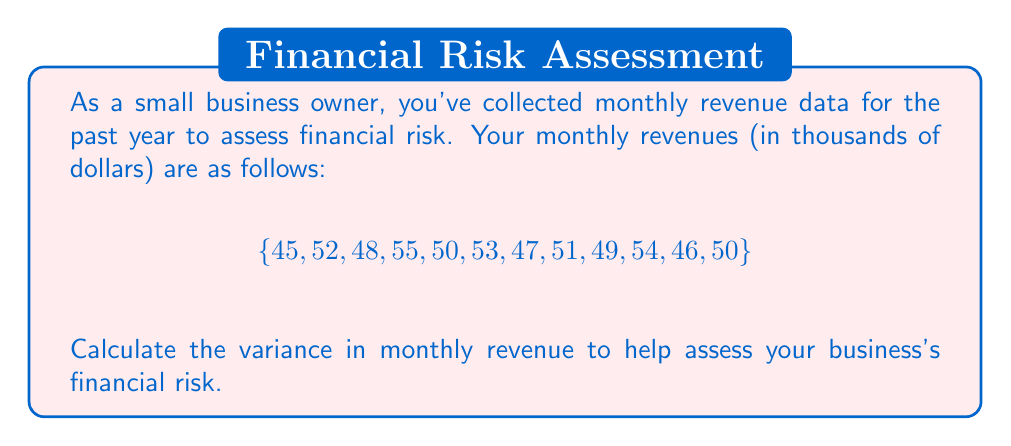Show me your answer to this math problem. To calculate the variance, we'll follow these steps:

1. Calculate the mean (average) revenue:
   $$\mu = \frac{\sum_{i=1}^{n} x_i}{n} = \frac{45 + 52 + 48 + 55 + 50 + 53 + 47 + 51 + 49 + 54 + 46 + 50}{12} = 50$$

2. Calculate the squared differences from the mean:
   $$(45-50)^2 = 25, (52-50)^2 = 4, (48-50)^2 = 4, (55-50)^2 = 25, (50-50)^2 = 0,$$
   $$(53-50)^2 = 9, (47-50)^2 = 9, (51-50)^2 = 1, (49-50)^2 = 1, (54-50)^2 = 16,$$
   $$(46-50)^2 = 16, (50-50)^2 = 0$$

3. Sum the squared differences:
   $$25 + 4 + 4 + 25 + 0 + 9 + 9 + 1 + 1 + 16 + 16 + 0 = 110$$

4. Divide by (n-1) to get the variance:
   $$\text{Variance} = \frac{\sum_{i=1}^{n} (x_i - \mu)^2}{n-1} = \frac{110}{11} = 10$$

Therefore, the variance in monthly revenue is 10 (thousand dollars squared).
Answer: $10,000^2$ 